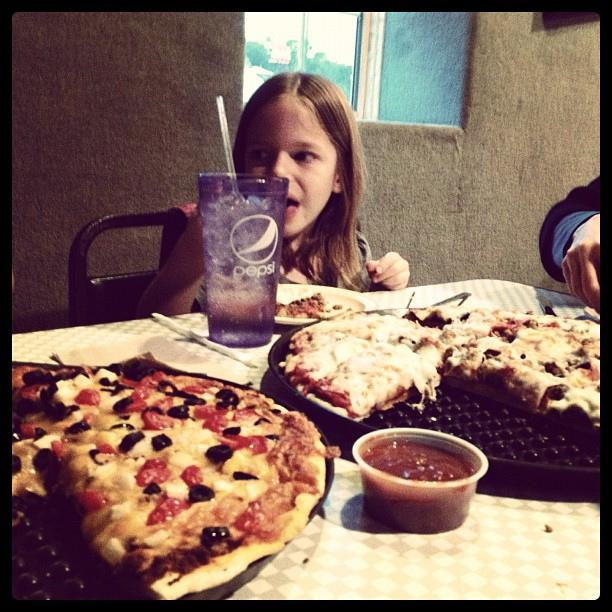What sort of sauce is found in the plastic cup? marinara 